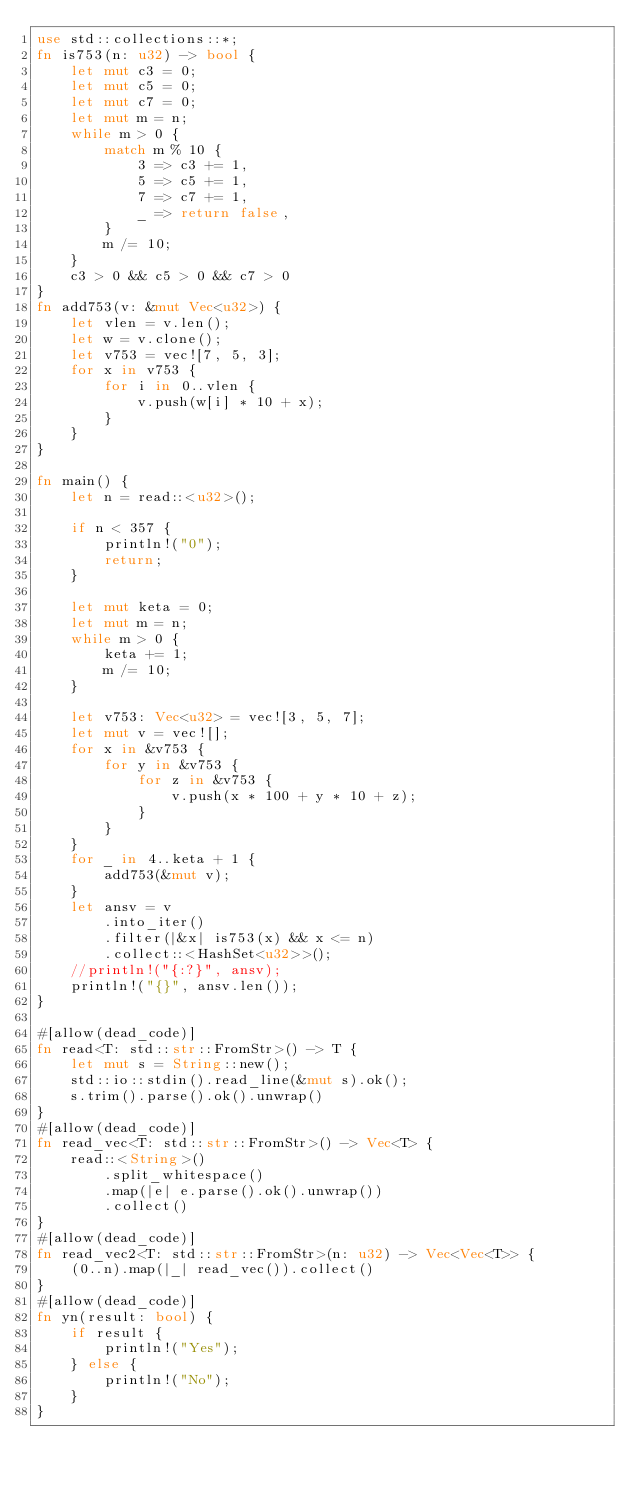<code> <loc_0><loc_0><loc_500><loc_500><_Rust_>use std::collections::*;
fn is753(n: u32) -> bool {
    let mut c3 = 0;
    let mut c5 = 0;
    let mut c7 = 0;
    let mut m = n;
    while m > 0 {
        match m % 10 {
            3 => c3 += 1,
            5 => c5 += 1,
            7 => c7 += 1,
            _ => return false,
        }
        m /= 10;
    }
    c3 > 0 && c5 > 0 && c7 > 0
}
fn add753(v: &mut Vec<u32>) {
    let vlen = v.len();
    let w = v.clone();
    let v753 = vec![7, 5, 3];
    for x in v753 {
        for i in 0..vlen {
            v.push(w[i] * 10 + x);
        }
    }
}

fn main() {
    let n = read::<u32>();

    if n < 357 {
        println!("0");
        return;
    }

    let mut keta = 0;
    let mut m = n;
    while m > 0 {
        keta += 1;
        m /= 10;
    }

    let v753: Vec<u32> = vec![3, 5, 7];
    let mut v = vec![];
    for x in &v753 {
        for y in &v753 {
            for z in &v753 {
                v.push(x * 100 + y * 10 + z);
            }
        }
    }
    for _ in 4..keta + 1 {
        add753(&mut v);
    }
    let ansv = v
        .into_iter()
        .filter(|&x| is753(x) && x <= n)
        .collect::<HashSet<u32>>();
    //println!("{:?}", ansv);
    println!("{}", ansv.len());
}

#[allow(dead_code)]
fn read<T: std::str::FromStr>() -> T {
    let mut s = String::new();
    std::io::stdin().read_line(&mut s).ok();
    s.trim().parse().ok().unwrap()
}
#[allow(dead_code)]
fn read_vec<T: std::str::FromStr>() -> Vec<T> {
    read::<String>()
        .split_whitespace()
        .map(|e| e.parse().ok().unwrap())
        .collect()
}
#[allow(dead_code)]
fn read_vec2<T: std::str::FromStr>(n: u32) -> Vec<Vec<T>> {
    (0..n).map(|_| read_vec()).collect()
}
#[allow(dead_code)]
fn yn(result: bool) {
    if result {
        println!("Yes");
    } else {
        println!("No");
    }
}
</code> 